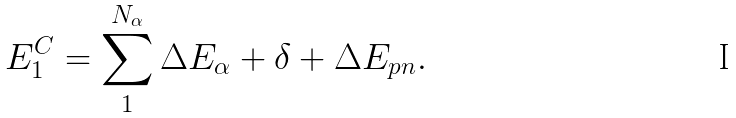<formula> <loc_0><loc_0><loc_500><loc_500>E ^ { C } _ { 1 } = \sum ^ { N _ { \alpha } } _ { 1 } \Delta E _ { \alpha } + \delta + \Delta E _ { p n } .</formula> 